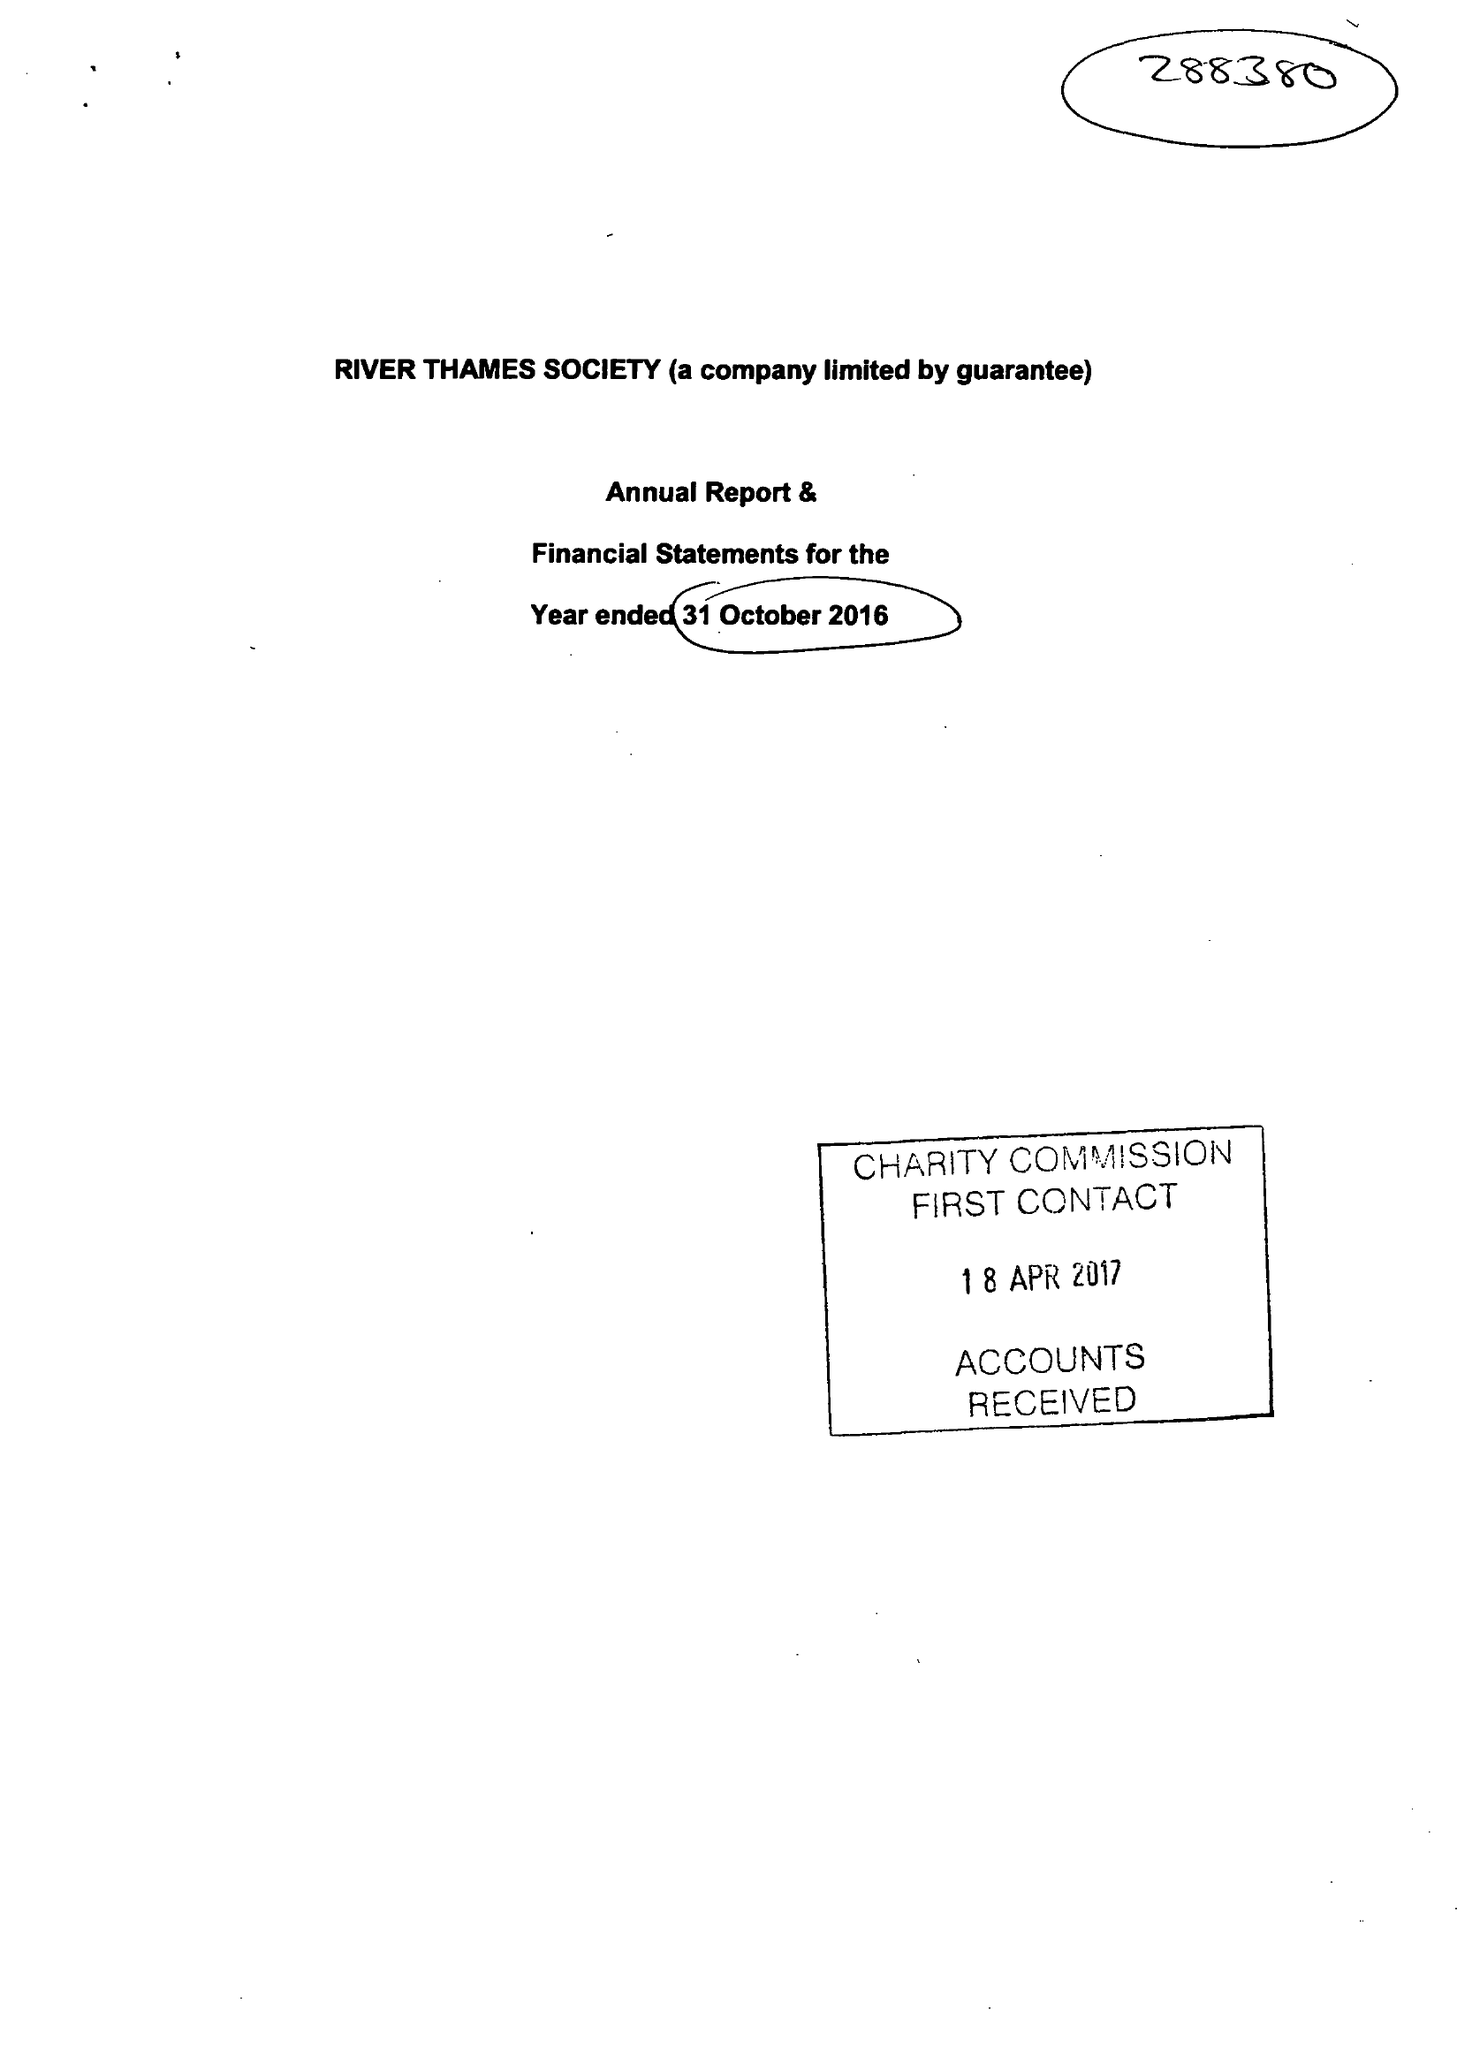What is the value for the charity_name?
Answer the question using a single word or phrase. River Thames Society 